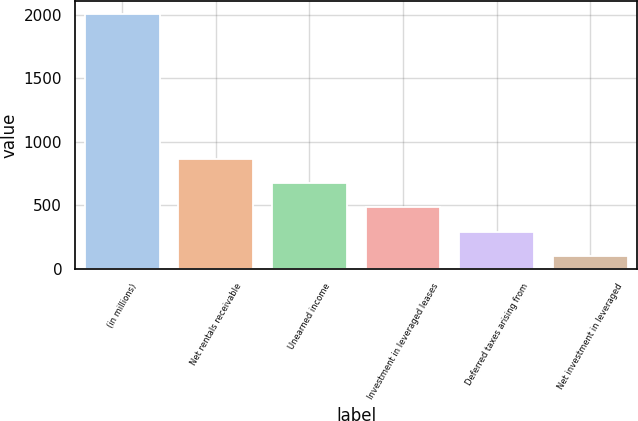Convert chart. <chart><loc_0><loc_0><loc_500><loc_500><bar_chart><fcel>(in millions)<fcel>Net rentals receivable<fcel>Unearned income<fcel>Investment in leveraged leases<fcel>Deferred taxes arising from<fcel>Net investment in leveraged<nl><fcel>2006<fcel>864.2<fcel>673.9<fcel>483.6<fcel>293.3<fcel>103<nl></chart> 